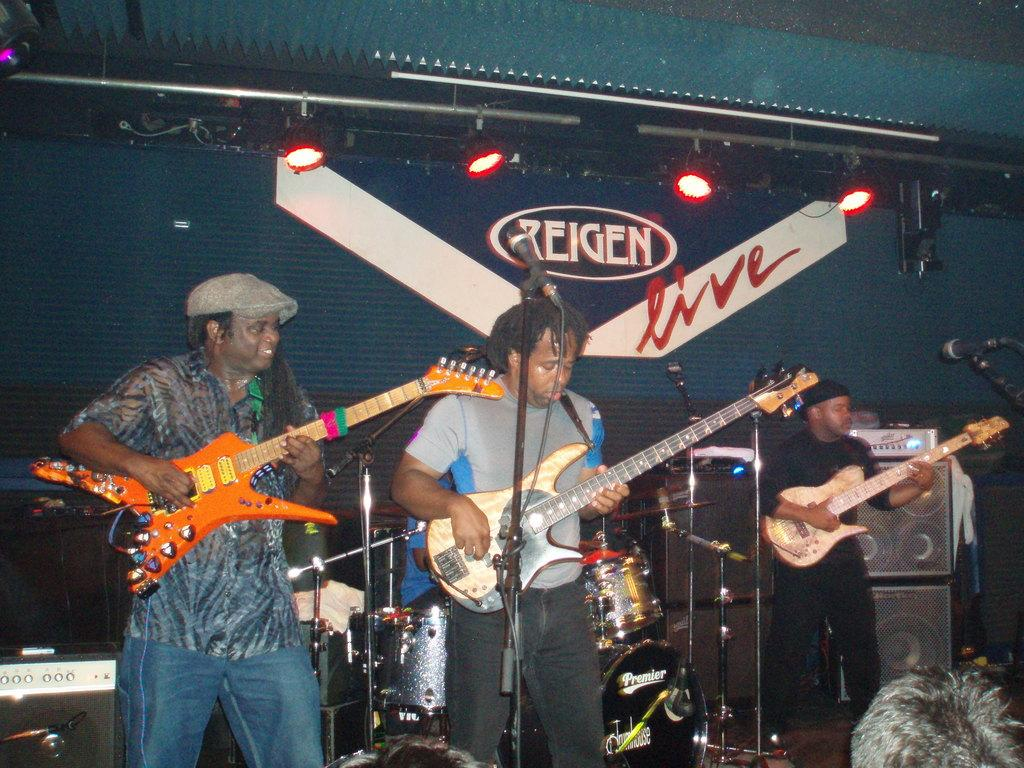How many men are in the image? There are three men in the image. What are the men doing in the image? The men are standing and holding guitars. What other items related to music can be seen in the image? There are microphones, speakers, and other musical instruments in the image. What can be seen in the image that might be used for amplifying sound? The speakers in the image can be used for amplifying sound. What type of rabbit can be seen drinking from a surprise in the image? There is no rabbit or surprise present in the image; it features three men holding guitars and other musical equipment. 